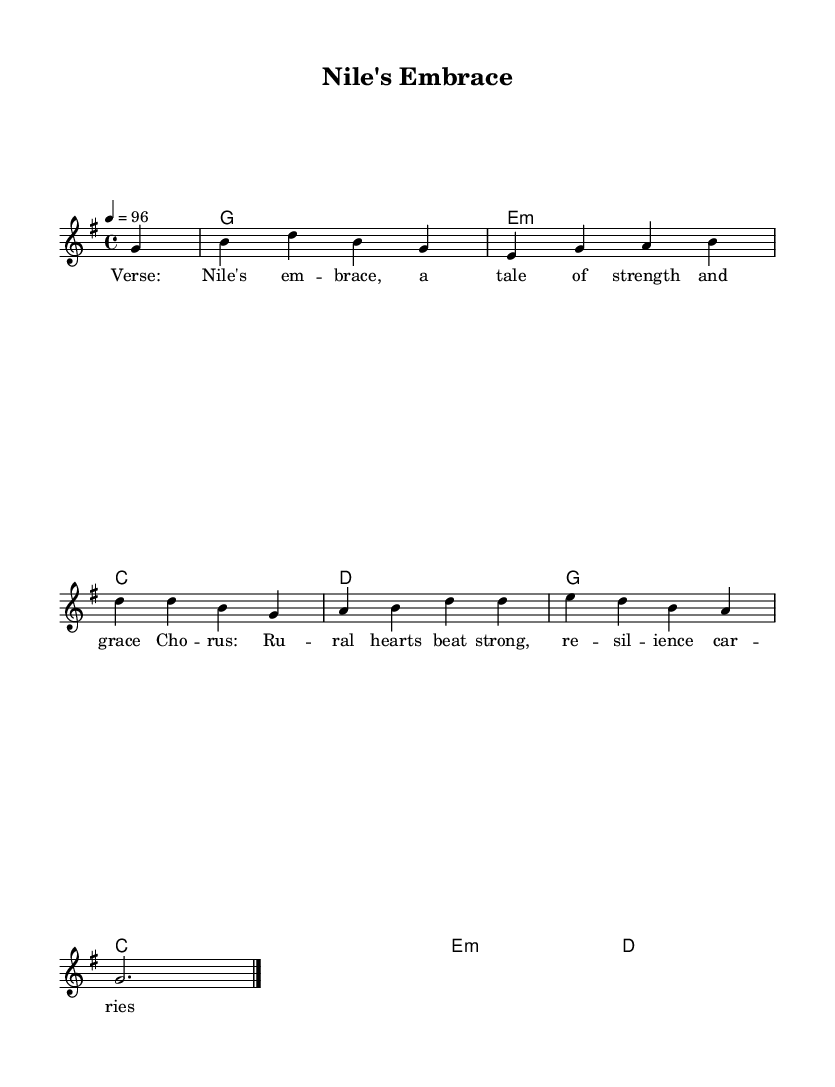What is the key signature of this music? The key signature is G major, which has one sharp (F#). This can be determined from the beginning of the score where the key signature is indicated.
Answer: G major What is the time signature of this piece? The time signature is 4/4, which means there are four beats in each measure, and the quarter note gets one beat. This is indicated at the start of the score after the key signature.
Answer: 4/4 What is the tempo marking for this piece? The tempo marking is 96 beats per minute, indicated in the score. This tells the performer how fast to play the piece.
Answer: 96 How many measures are in the melody? The melody consists of four measures, as can be counted from the individual music notation lines and spaces in the staff above the chord names.
Answer: Four What is the emotional theme conveyed by the lyrics? The emotional theme conveyed by the lyrics is resilience and strength, focusing on rural communities, as suggested by the lyrics that emphasize enduring spirit. This can be inferred from the choice of words in the lyrics accompanied by the music.
Answer: Resilience What type of chord is used in the second measure? The second measure contains a G major chord, which can be identified by the notes that create this chord in the context of the harmony indicated in the chord mode section.
Answer: G major What aligns the lyrics with their corresponding melody? The melody notes correspond to the syllables of the lyrics, with each note matching a syllable, indicated in the lyrics section underneath the melody. This structure helps in aligning the vocal delivery with the music rhythmically.
Answer: Syllable alignment 